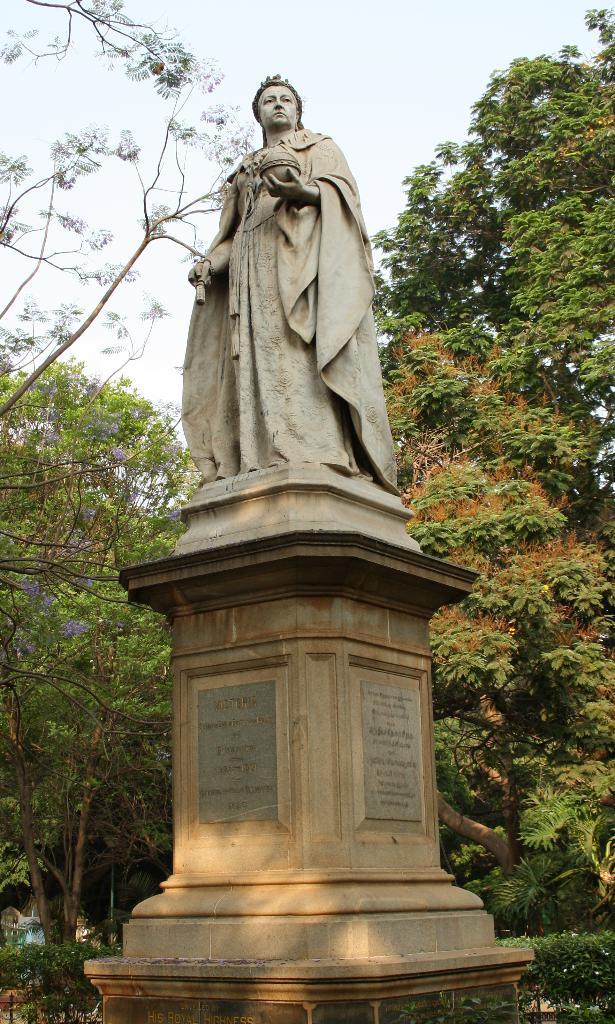What is the main subject of the image? There is a statue in the image. Can you describe the colors of the statue? The statue has brown and cream colors. What can be seen in the background of the image? There are green color trees in the background. How would you describe the color of the sky in the image? The sky appears to be white in color. What year is depicted on the base of the statue? There is no indication of a specific year on the base of the statue in the image. How many yams are present in the image? There are no yams present in the image; the focus is on the statue and its colors, as well as the background elements. 